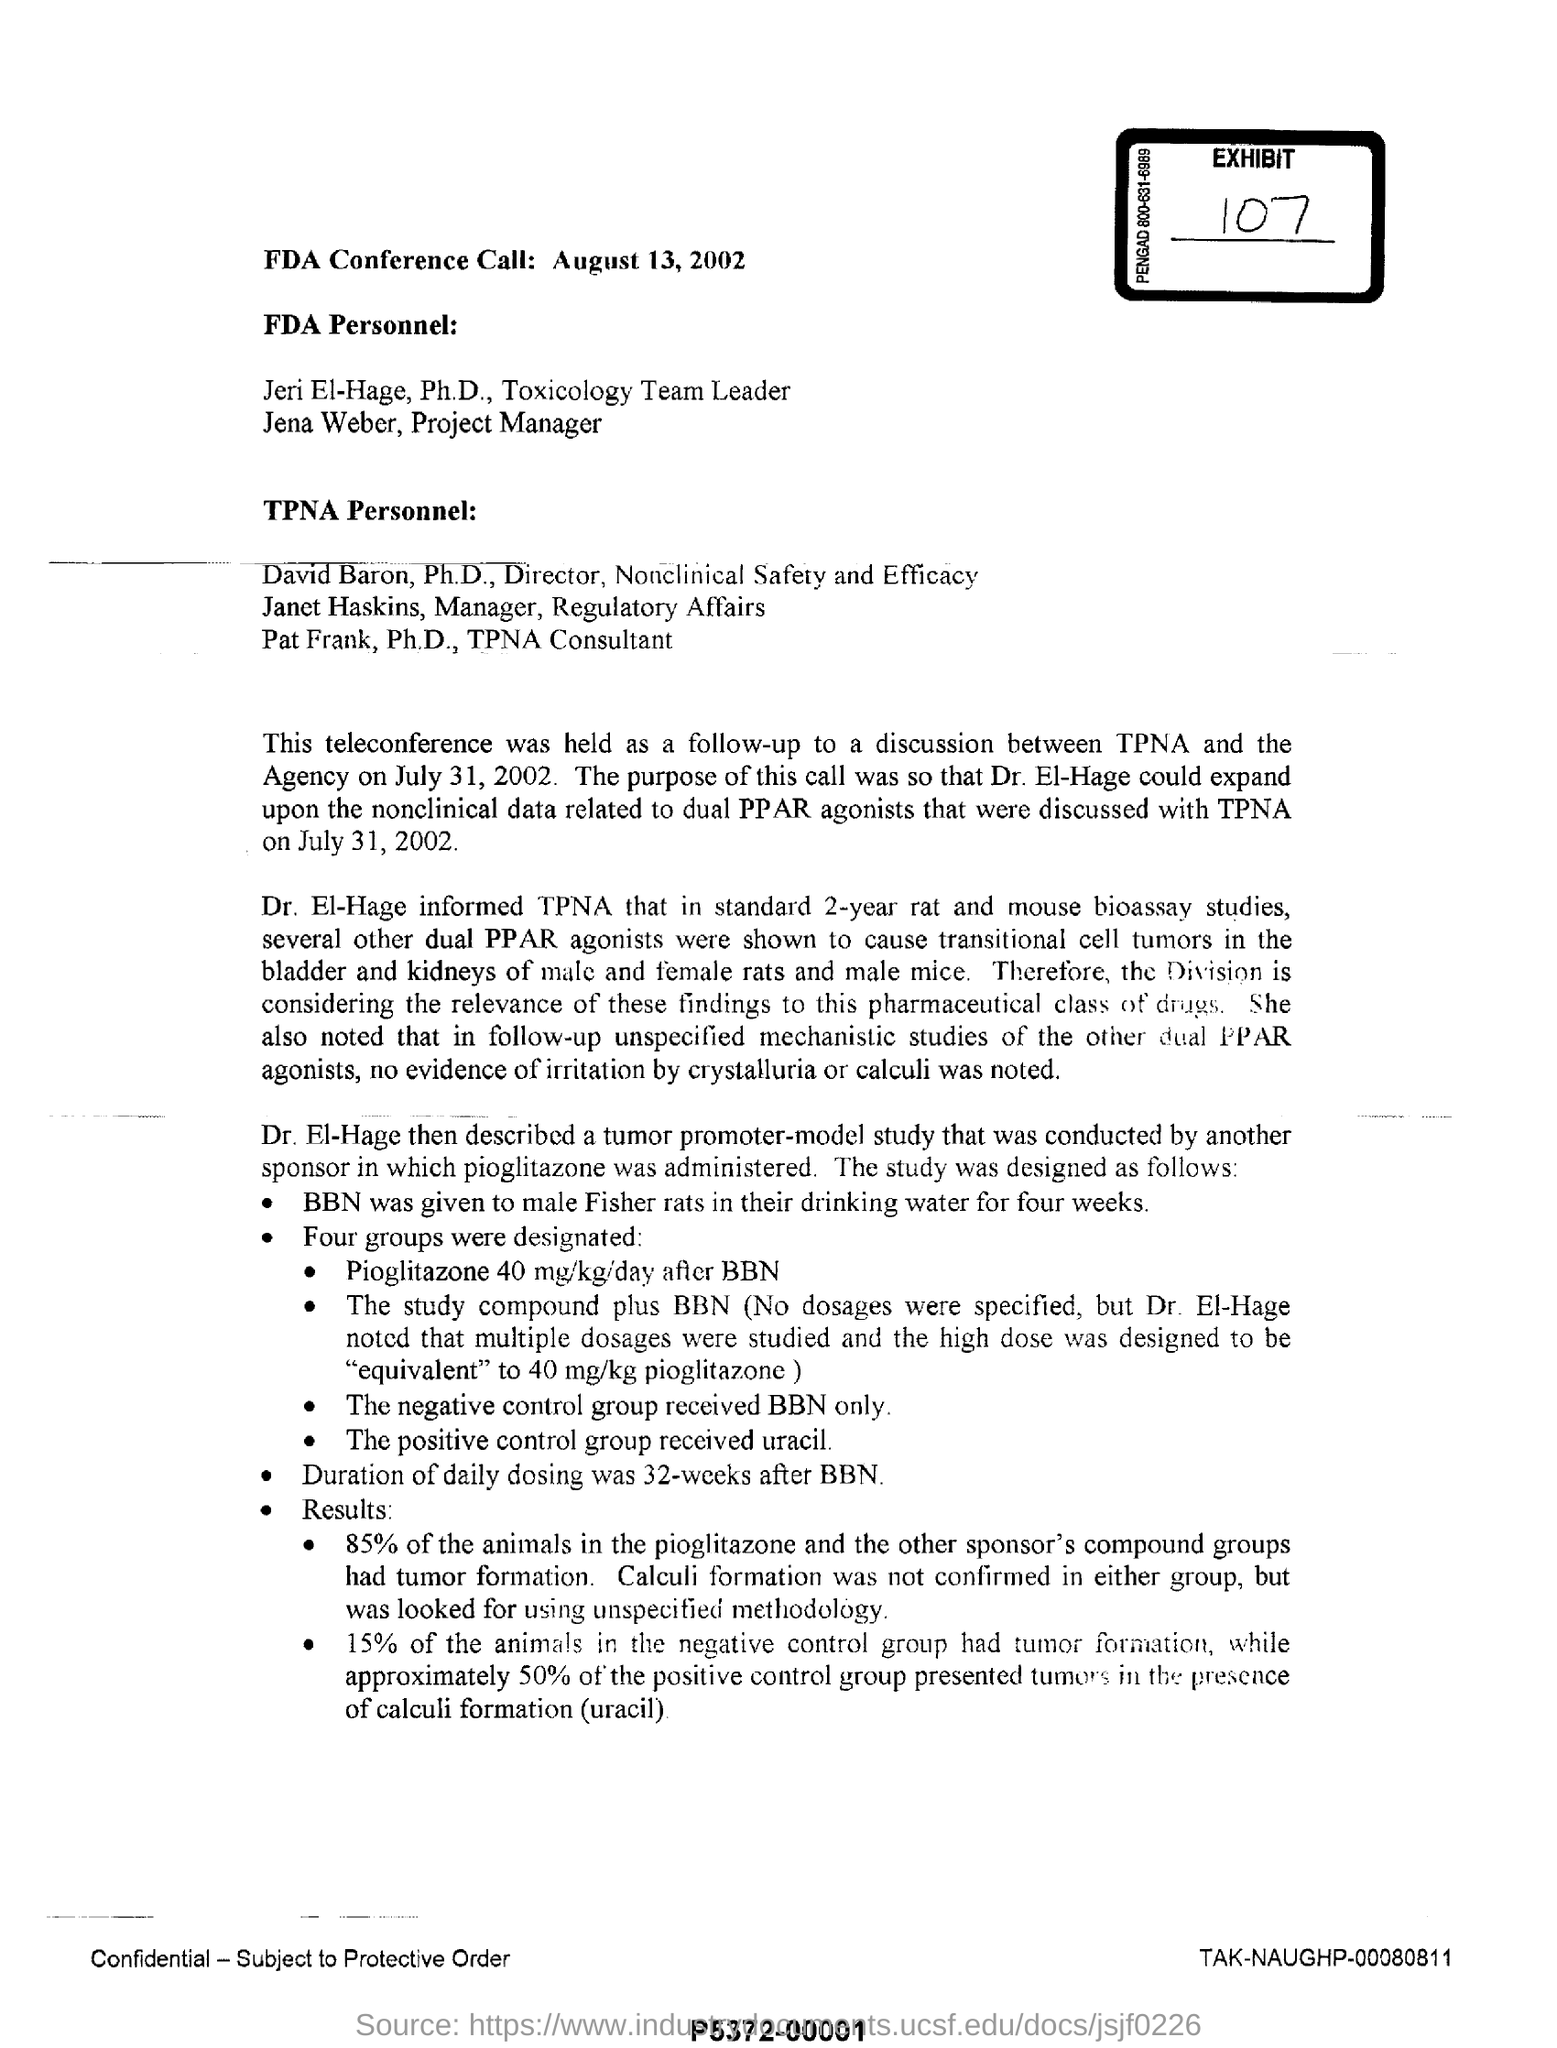Highlight a few significant elements in this photo. The tumor promoter-model study was described by Dr. El-Hage. The exhibit number is 107. The duration of daily dosing is 32 weeks. The Director of Nonclinical Safety and Efficacy is David Baron. The issued date of this document is August 13, 2002. 